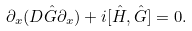<formula> <loc_0><loc_0><loc_500><loc_500>\partial _ { x } ( D \hat { G } \partial _ { x } ) + i [ \hat { H } , \hat { G } ] = 0 .</formula> 